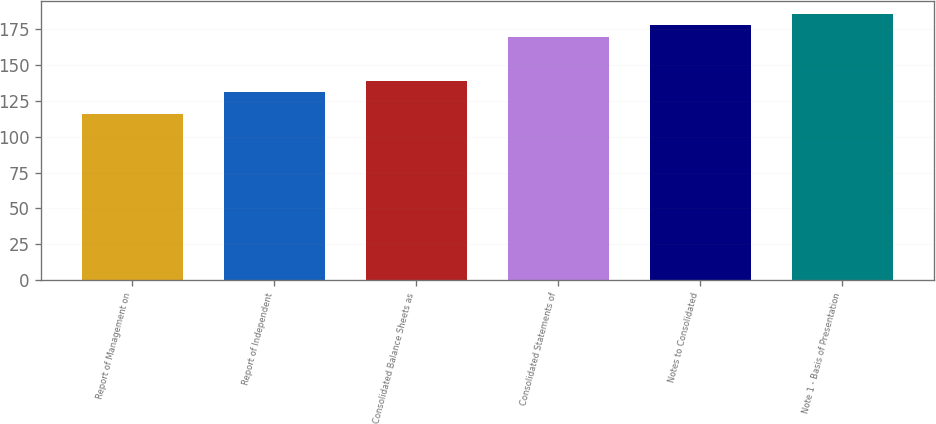Convert chart. <chart><loc_0><loc_0><loc_500><loc_500><bar_chart><fcel>Report of Management on<fcel>Report of Independent<fcel>Consolidated Balance Sheets as<fcel>Consolidated Statements of<fcel>Notes to Consolidated<fcel>Note 1 - Basis of Presentation<nl><fcel>116<fcel>131.4<fcel>139.1<fcel>169.9<fcel>177.6<fcel>185.3<nl></chart> 